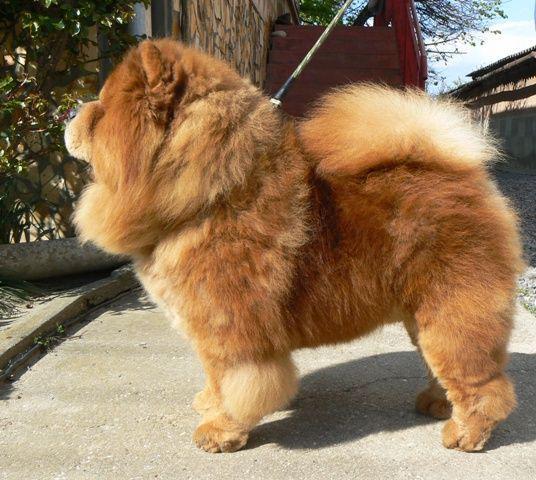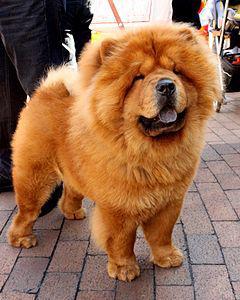The first image is the image on the left, the second image is the image on the right. For the images shown, is this caption "One of the images contains a dog that is laying down." true? Answer yes or no. No. 